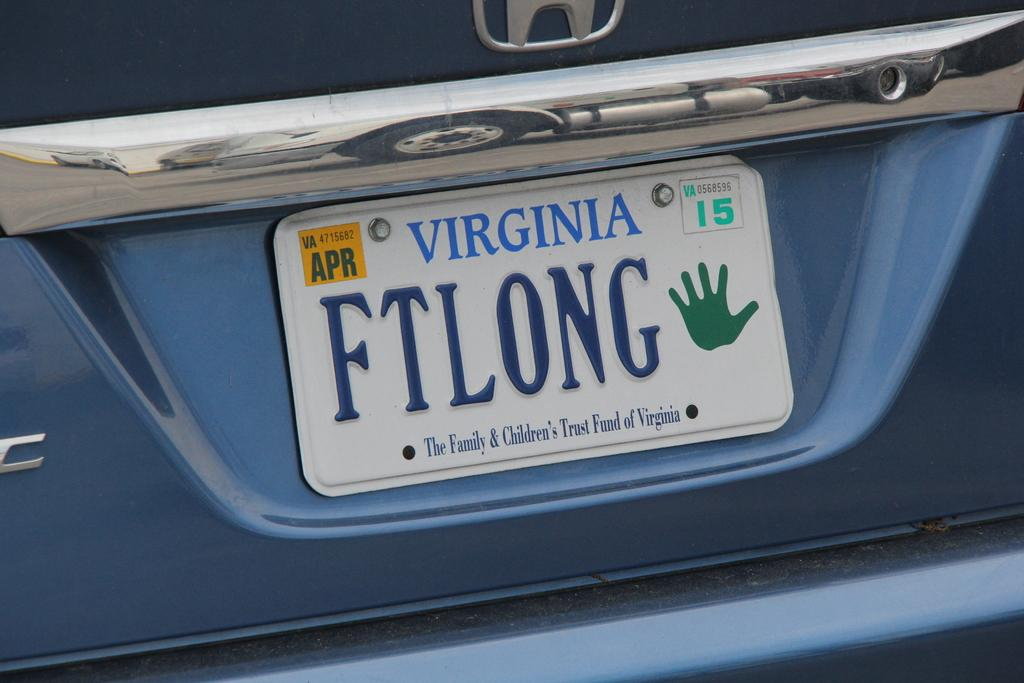<image>
Offer a succinct explanation of the picture presented. A Virginia license plate says "FTLONG" on it with a green hand. 